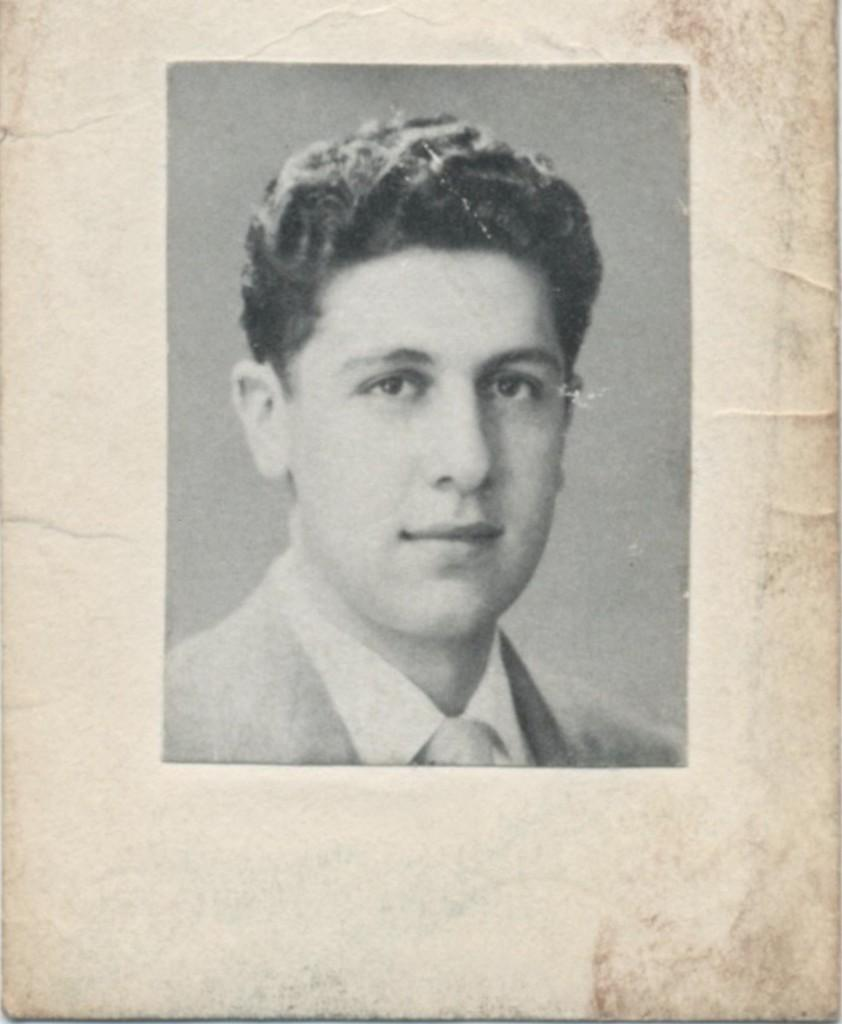What is the main subject of the image? There is a photograph of a man in the image. What type of wire is being used to control the horses in the image? There are no horses or wires present in the image; it features a photograph of a man. 